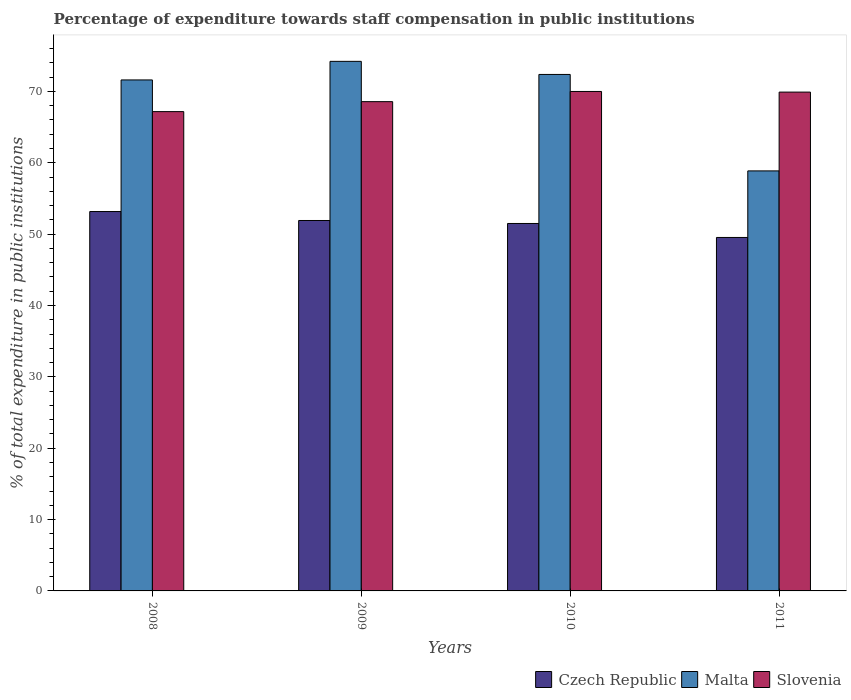How many groups of bars are there?
Give a very brief answer. 4. Are the number of bars on each tick of the X-axis equal?
Your response must be concise. Yes. What is the percentage of expenditure towards staff compensation in Malta in 2008?
Your answer should be very brief. 71.6. Across all years, what is the maximum percentage of expenditure towards staff compensation in Czech Republic?
Provide a short and direct response. 53.16. Across all years, what is the minimum percentage of expenditure towards staff compensation in Czech Republic?
Your answer should be very brief. 49.53. In which year was the percentage of expenditure towards staff compensation in Slovenia minimum?
Ensure brevity in your answer.  2008. What is the total percentage of expenditure towards staff compensation in Czech Republic in the graph?
Provide a succinct answer. 206.09. What is the difference between the percentage of expenditure towards staff compensation in Slovenia in 2008 and that in 2010?
Provide a succinct answer. -2.82. What is the difference between the percentage of expenditure towards staff compensation in Malta in 2008 and the percentage of expenditure towards staff compensation in Slovenia in 2009?
Provide a short and direct response. 3.04. What is the average percentage of expenditure towards staff compensation in Malta per year?
Provide a short and direct response. 69.26. In the year 2008, what is the difference between the percentage of expenditure towards staff compensation in Slovenia and percentage of expenditure towards staff compensation in Czech Republic?
Your answer should be compact. 14. What is the ratio of the percentage of expenditure towards staff compensation in Czech Republic in 2010 to that in 2011?
Provide a short and direct response. 1.04. Is the percentage of expenditure towards staff compensation in Czech Republic in 2009 less than that in 2010?
Make the answer very short. No. What is the difference between the highest and the second highest percentage of expenditure towards staff compensation in Malta?
Offer a terse response. 1.83. What is the difference between the highest and the lowest percentage of expenditure towards staff compensation in Slovenia?
Make the answer very short. 2.82. In how many years, is the percentage of expenditure towards staff compensation in Malta greater than the average percentage of expenditure towards staff compensation in Malta taken over all years?
Provide a short and direct response. 3. Is the sum of the percentage of expenditure towards staff compensation in Czech Republic in 2008 and 2011 greater than the maximum percentage of expenditure towards staff compensation in Malta across all years?
Your response must be concise. Yes. What does the 1st bar from the left in 2008 represents?
Give a very brief answer. Czech Republic. What does the 2nd bar from the right in 2011 represents?
Your answer should be compact. Malta. Is it the case that in every year, the sum of the percentage of expenditure towards staff compensation in Czech Republic and percentage of expenditure towards staff compensation in Malta is greater than the percentage of expenditure towards staff compensation in Slovenia?
Provide a succinct answer. Yes. How many bars are there?
Your response must be concise. 12. Are all the bars in the graph horizontal?
Provide a succinct answer. No. What is the difference between two consecutive major ticks on the Y-axis?
Your answer should be compact. 10. Does the graph contain any zero values?
Give a very brief answer. No. Does the graph contain grids?
Give a very brief answer. No. Where does the legend appear in the graph?
Give a very brief answer. Bottom right. How are the legend labels stacked?
Make the answer very short. Horizontal. What is the title of the graph?
Give a very brief answer. Percentage of expenditure towards staff compensation in public institutions. Does "American Samoa" appear as one of the legend labels in the graph?
Keep it short and to the point. No. What is the label or title of the X-axis?
Provide a succinct answer. Years. What is the label or title of the Y-axis?
Your response must be concise. % of total expenditure in public institutions. What is the % of total expenditure in public institutions of Czech Republic in 2008?
Your answer should be very brief. 53.16. What is the % of total expenditure in public institutions of Malta in 2008?
Ensure brevity in your answer.  71.6. What is the % of total expenditure in public institutions of Slovenia in 2008?
Offer a terse response. 67.16. What is the % of total expenditure in public institutions of Czech Republic in 2009?
Your response must be concise. 51.91. What is the % of total expenditure in public institutions in Malta in 2009?
Make the answer very short. 74.21. What is the % of total expenditure in public institutions of Slovenia in 2009?
Provide a succinct answer. 68.56. What is the % of total expenditure in public institutions of Czech Republic in 2010?
Provide a succinct answer. 51.49. What is the % of total expenditure in public institutions in Malta in 2010?
Offer a terse response. 72.37. What is the % of total expenditure in public institutions in Slovenia in 2010?
Keep it short and to the point. 69.99. What is the % of total expenditure in public institutions of Czech Republic in 2011?
Offer a terse response. 49.53. What is the % of total expenditure in public institutions of Malta in 2011?
Provide a succinct answer. 58.86. What is the % of total expenditure in public institutions in Slovenia in 2011?
Give a very brief answer. 69.9. Across all years, what is the maximum % of total expenditure in public institutions in Czech Republic?
Your answer should be very brief. 53.16. Across all years, what is the maximum % of total expenditure in public institutions of Malta?
Keep it short and to the point. 74.21. Across all years, what is the maximum % of total expenditure in public institutions in Slovenia?
Ensure brevity in your answer.  69.99. Across all years, what is the minimum % of total expenditure in public institutions in Czech Republic?
Give a very brief answer. 49.53. Across all years, what is the minimum % of total expenditure in public institutions in Malta?
Make the answer very short. 58.86. Across all years, what is the minimum % of total expenditure in public institutions in Slovenia?
Give a very brief answer. 67.16. What is the total % of total expenditure in public institutions in Czech Republic in the graph?
Make the answer very short. 206.09. What is the total % of total expenditure in public institutions in Malta in the graph?
Your answer should be very brief. 277.04. What is the total % of total expenditure in public institutions of Slovenia in the graph?
Your answer should be very brief. 275.61. What is the difference between the % of total expenditure in public institutions of Czech Republic in 2008 and that in 2009?
Offer a very short reply. 1.25. What is the difference between the % of total expenditure in public institutions in Malta in 2008 and that in 2009?
Your answer should be compact. -2.6. What is the difference between the % of total expenditure in public institutions of Slovenia in 2008 and that in 2009?
Provide a succinct answer. -1.4. What is the difference between the % of total expenditure in public institutions of Czech Republic in 2008 and that in 2010?
Offer a very short reply. 1.67. What is the difference between the % of total expenditure in public institutions of Malta in 2008 and that in 2010?
Ensure brevity in your answer.  -0.77. What is the difference between the % of total expenditure in public institutions in Slovenia in 2008 and that in 2010?
Make the answer very short. -2.82. What is the difference between the % of total expenditure in public institutions of Czech Republic in 2008 and that in 2011?
Your response must be concise. 3.63. What is the difference between the % of total expenditure in public institutions of Malta in 2008 and that in 2011?
Offer a terse response. 12.75. What is the difference between the % of total expenditure in public institutions in Slovenia in 2008 and that in 2011?
Your answer should be very brief. -2.73. What is the difference between the % of total expenditure in public institutions in Czech Republic in 2009 and that in 2010?
Provide a succinct answer. 0.42. What is the difference between the % of total expenditure in public institutions of Malta in 2009 and that in 2010?
Give a very brief answer. 1.83. What is the difference between the % of total expenditure in public institutions of Slovenia in 2009 and that in 2010?
Your response must be concise. -1.43. What is the difference between the % of total expenditure in public institutions of Czech Republic in 2009 and that in 2011?
Your response must be concise. 2.38. What is the difference between the % of total expenditure in public institutions in Malta in 2009 and that in 2011?
Keep it short and to the point. 15.35. What is the difference between the % of total expenditure in public institutions in Slovenia in 2009 and that in 2011?
Provide a succinct answer. -1.34. What is the difference between the % of total expenditure in public institutions in Czech Republic in 2010 and that in 2011?
Offer a terse response. 1.96. What is the difference between the % of total expenditure in public institutions of Malta in 2010 and that in 2011?
Provide a succinct answer. 13.51. What is the difference between the % of total expenditure in public institutions of Slovenia in 2010 and that in 2011?
Provide a short and direct response. 0.09. What is the difference between the % of total expenditure in public institutions of Czech Republic in 2008 and the % of total expenditure in public institutions of Malta in 2009?
Provide a short and direct response. -21.05. What is the difference between the % of total expenditure in public institutions in Czech Republic in 2008 and the % of total expenditure in public institutions in Slovenia in 2009?
Offer a very short reply. -15.4. What is the difference between the % of total expenditure in public institutions of Malta in 2008 and the % of total expenditure in public institutions of Slovenia in 2009?
Your answer should be compact. 3.04. What is the difference between the % of total expenditure in public institutions in Czech Republic in 2008 and the % of total expenditure in public institutions in Malta in 2010?
Keep it short and to the point. -19.21. What is the difference between the % of total expenditure in public institutions of Czech Republic in 2008 and the % of total expenditure in public institutions of Slovenia in 2010?
Offer a very short reply. -16.83. What is the difference between the % of total expenditure in public institutions in Malta in 2008 and the % of total expenditure in public institutions in Slovenia in 2010?
Provide a short and direct response. 1.61. What is the difference between the % of total expenditure in public institutions in Czech Republic in 2008 and the % of total expenditure in public institutions in Malta in 2011?
Provide a short and direct response. -5.7. What is the difference between the % of total expenditure in public institutions of Czech Republic in 2008 and the % of total expenditure in public institutions of Slovenia in 2011?
Your answer should be compact. -16.74. What is the difference between the % of total expenditure in public institutions in Malta in 2008 and the % of total expenditure in public institutions in Slovenia in 2011?
Offer a terse response. 1.7. What is the difference between the % of total expenditure in public institutions of Czech Republic in 2009 and the % of total expenditure in public institutions of Malta in 2010?
Make the answer very short. -20.47. What is the difference between the % of total expenditure in public institutions in Czech Republic in 2009 and the % of total expenditure in public institutions in Slovenia in 2010?
Ensure brevity in your answer.  -18.08. What is the difference between the % of total expenditure in public institutions in Malta in 2009 and the % of total expenditure in public institutions in Slovenia in 2010?
Provide a short and direct response. 4.22. What is the difference between the % of total expenditure in public institutions in Czech Republic in 2009 and the % of total expenditure in public institutions in Malta in 2011?
Give a very brief answer. -6.95. What is the difference between the % of total expenditure in public institutions in Czech Republic in 2009 and the % of total expenditure in public institutions in Slovenia in 2011?
Make the answer very short. -17.99. What is the difference between the % of total expenditure in public institutions in Malta in 2009 and the % of total expenditure in public institutions in Slovenia in 2011?
Your response must be concise. 4.31. What is the difference between the % of total expenditure in public institutions in Czech Republic in 2010 and the % of total expenditure in public institutions in Malta in 2011?
Your answer should be compact. -7.37. What is the difference between the % of total expenditure in public institutions of Czech Republic in 2010 and the % of total expenditure in public institutions of Slovenia in 2011?
Your answer should be compact. -18.41. What is the difference between the % of total expenditure in public institutions of Malta in 2010 and the % of total expenditure in public institutions of Slovenia in 2011?
Your answer should be compact. 2.47. What is the average % of total expenditure in public institutions in Czech Republic per year?
Your answer should be very brief. 51.52. What is the average % of total expenditure in public institutions of Malta per year?
Your response must be concise. 69.26. What is the average % of total expenditure in public institutions in Slovenia per year?
Your answer should be compact. 68.9. In the year 2008, what is the difference between the % of total expenditure in public institutions of Czech Republic and % of total expenditure in public institutions of Malta?
Offer a very short reply. -18.44. In the year 2008, what is the difference between the % of total expenditure in public institutions in Czech Republic and % of total expenditure in public institutions in Slovenia?
Your answer should be compact. -14. In the year 2008, what is the difference between the % of total expenditure in public institutions in Malta and % of total expenditure in public institutions in Slovenia?
Ensure brevity in your answer.  4.44. In the year 2009, what is the difference between the % of total expenditure in public institutions in Czech Republic and % of total expenditure in public institutions in Malta?
Ensure brevity in your answer.  -22.3. In the year 2009, what is the difference between the % of total expenditure in public institutions of Czech Republic and % of total expenditure in public institutions of Slovenia?
Offer a very short reply. -16.65. In the year 2009, what is the difference between the % of total expenditure in public institutions of Malta and % of total expenditure in public institutions of Slovenia?
Give a very brief answer. 5.65. In the year 2010, what is the difference between the % of total expenditure in public institutions of Czech Republic and % of total expenditure in public institutions of Malta?
Your answer should be very brief. -20.88. In the year 2010, what is the difference between the % of total expenditure in public institutions of Czech Republic and % of total expenditure in public institutions of Slovenia?
Ensure brevity in your answer.  -18.5. In the year 2010, what is the difference between the % of total expenditure in public institutions in Malta and % of total expenditure in public institutions in Slovenia?
Make the answer very short. 2.38. In the year 2011, what is the difference between the % of total expenditure in public institutions in Czech Republic and % of total expenditure in public institutions in Malta?
Your response must be concise. -9.33. In the year 2011, what is the difference between the % of total expenditure in public institutions of Czech Republic and % of total expenditure in public institutions of Slovenia?
Provide a short and direct response. -20.37. In the year 2011, what is the difference between the % of total expenditure in public institutions in Malta and % of total expenditure in public institutions in Slovenia?
Your answer should be very brief. -11.04. What is the ratio of the % of total expenditure in public institutions of Czech Republic in 2008 to that in 2009?
Your response must be concise. 1.02. What is the ratio of the % of total expenditure in public institutions of Malta in 2008 to that in 2009?
Ensure brevity in your answer.  0.96. What is the ratio of the % of total expenditure in public institutions in Slovenia in 2008 to that in 2009?
Keep it short and to the point. 0.98. What is the ratio of the % of total expenditure in public institutions of Czech Republic in 2008 to that in 2010?
Make the answer very short. 1.03. What is the ratio of the % of total expenditure in public institutions of Malta in 2008 to that in 2010?
Provide a short and direct response. 0.99. What is the ratio of the % of total expenditure in public institutions in Slovenia in 2008 to that in 2010?
Make the answer very short. 0.96. What is the ratio of the % of total expenditure in public institutions in Czech Republic in 2008 to that in 2011?
Offer a terse response. 1.07. What is the ratio of the % of total expenditure in public institutions in Malta in 2008 to that in 2011?
Give a very brief answer. 1.22. What is the ratio of the % of total expenditure in public institutions in Slovenia in 2008 to that in 2011?
Ensure brevity in your answer.  0.96. What is the ratio of the % of total expenditure in public institutions of Malta in 2009 to that in 2010?
Make the answer very short. 1.03. What is the ratio of the % of total expenditure in public institutions in Slovenia in 2009 to that in 2010?
Your response must be concise. 0.98. What is the ratio of the % of total expenditure in public institutions of Czech Republic in 2009 to that in 2011?
Ensure brevity in your answer.  1.05. What is the ratio of the % of total expenditure in public institutions of Malta in 2009 to that in 2011?
Your response must be concise. 1.26. What is the ratio of the % of total expenditure in public institutions of Slovenia in 2009 to that in 2011?
Give a very brief answer. 0.98. What is the ratio of the % of total expenditure in public institutions in Czech Republic in 2010 to that in 2011?
Ensure brevity in your answer.  1.04. What is the ratio of the % of total expenditure in public institutions of Malta in 2010 to that in 2011?
Your response must be concise. 1.23. What is the difference between the highest and the second highest % of total expenditure in public institutions in Czech Republic?
Offer a very short reply. 1.25. What is the difference between the highest and the second highest % of total expenditure in public institutions in Malta?
Provide a succinct answer. 1.83. What is the difference between the highest and the second highest % of total expenditure in public institutions in Slovenia?
Offer a terse response. 0.09. What is the difference between the highest and the lowest % of total expenditure in public institutions in Czech Republic?
Keep it short and to the point. 3.63. What is the difference between the highest and the lowest % of total expenditure in public institutions in Malta?
Give a very brief answer. 15.35. What is the difference between the highest and the lowest % of total expenditure in public institutions of Slovenia?
Your answer should be compact. 2.82. 